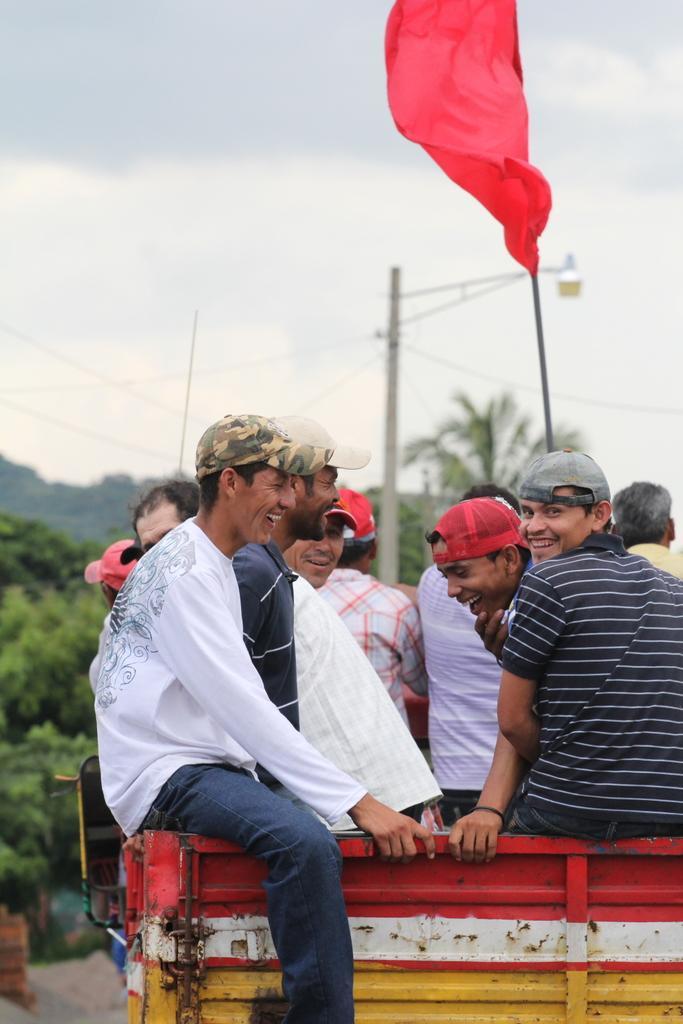How would you summarize this image in a sentence or two? In this image there are many people in the back of a vehicle. Most of them are smiling. Here there is a red flag. In the background there are trees, electric pole. The sky is cloudy. 